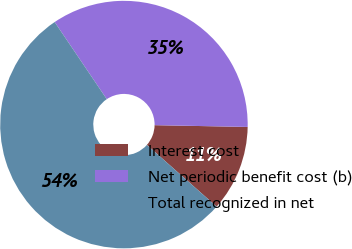Convert chart. <chart><loc_0><loc_0><loc_500><loc_500><pie_chart><fcel>Interest cost<fcel>Net periodic benefit cost (b)<fcel>Total recognized in net<nl><fcel>11.23%<fcel>34.76%<fcel>54.01%<nl></chart> 